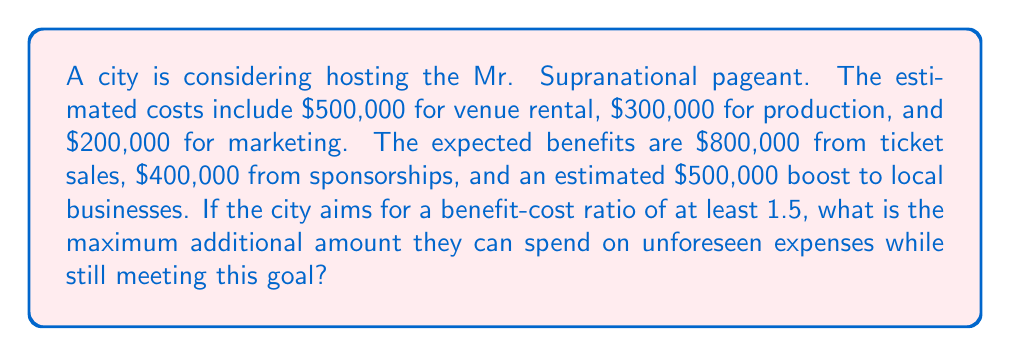Provide a solution to this math problem. Let's approach this step-by-step using cost-benefit analysis:

1) First, calculate the total known costs:
   $$ \text{Total Costs} = 500,000 + 300,000 + 200,000 = \$1,000,000 $$

2) Next, calculate the total benefits:
   $$ \text{Total Benefits} = 800,000 + 400,000 + 500,000 = \$1,700,000 $$

3) The benefit-cost ratio (BCR) is defined as:
   $$ \text{BCR} = \frac{\text{Total Benefits}}{\text{Total Costs}} $$

4) The city wants a BCR of at least 1.5. Let $x$ be the maximum additional amount they can spend. Then:
   $$ \frac{1,700,000}{1,000,000 + x} \geq 1.5 $$

5) Solve this inequality:
   $$ 1,700,000 \geq 1.5(1,000,000 + x) $$
   $$ 1,700,000 \geq 1,500,000 + 1.5x $$
   $$ 200,000 \geq 1.5x $$
   $$ \frac{200,000}{1.5} \geq x $$
   $$ 133,333.33 \geq x $$

6) Therefore, the maximum additional amount they can spend while maintaining a BCR of 1.5 is $133,333.33.
Answer: $133,333.33 